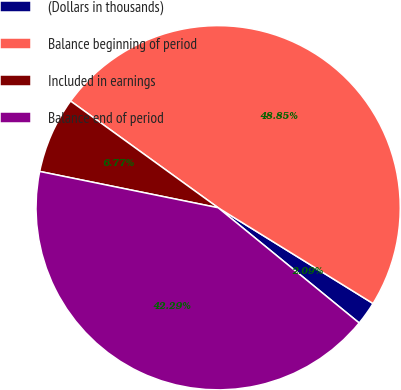Convert chart to OTSL. <chart><loc_0><loc_0><loc_500><loc_500><pie_chart><fcel>(Dollars in thousands)<fcel>Balance beginning of period<fcel>Included in earnings<fcel>Balance end of period<nl><fcel>2.09%<fcel>48.85%<fcel>6.77%<fcel>42.29%<nl></chart> 